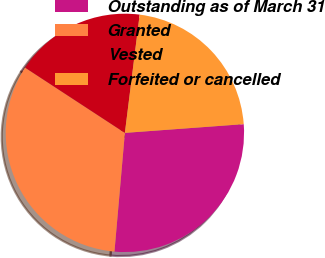Convert chart. <chart><loc_0><loc_0><loc_500><loc_500><pie_chart><fcel>Outstanding as of March 31<fcel>Granted<fcel>Vested<fcel>Forfeited or cancelled<nl><fcel>27.56%<fcel>32.82%<fcel>17.76%<fcel>21.85%<nl></chart> 